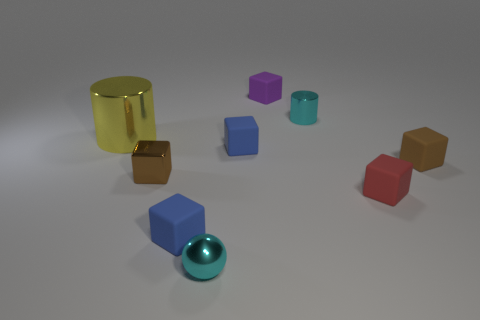Subtract all red blocks. How many blocks are left? 5 Subtract all red cubes. How many cubes are left? 5 Subtract all purple blocks. Subtract all brown balls. How many blocks are left? 5 Add 1 big blue metal cylinders. How many objects exist? 10 Subtract all blocks. How many objects are left? 3 Subtract all tiny blue matte things. Subtract all tiny purple rubber objects. How many objects are left? 6 Add 3 tiny brown objects. How many tiny brown objects are left? 5 Add 1 shiny things. How many shiny things exist? 5 Subtract 0 brown balls. How many objects are left? 9 